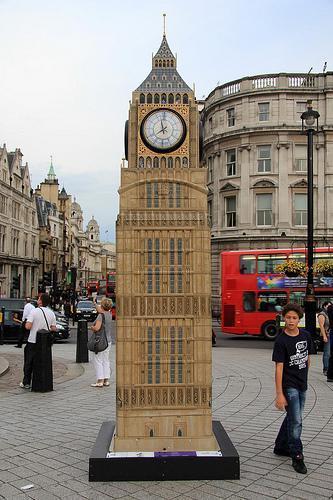How many statues are shown?
Give a very brief answer. 1. 